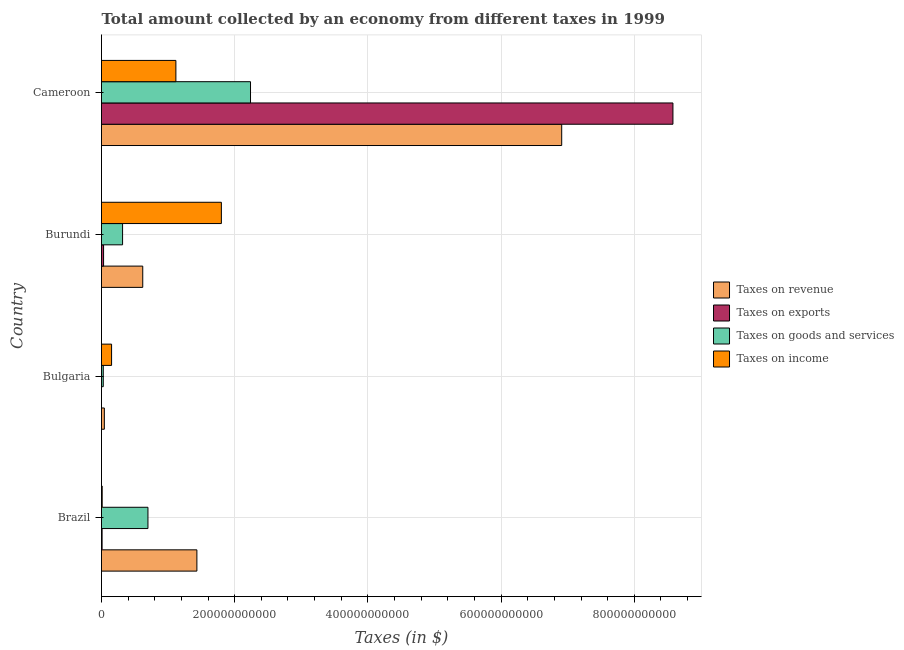How many different coloured bars are there?
Offer a very short reply. 4. How many groups of bars are there?
Provide a short and direct response. 4. Are the number of bars per tick equal to the number of legend labels?
Provide a short and direct response. No. Are the number of bars on each tick of the Y-axis equal?
Ensure brevity in your answer.  No. What is the label of the 2nd group of bars from the top?
Provide a short and direct response. Burundi. What is the amount collected as tax on income in Burundi?
Offer a terse response. 1.80e+11. Across all countries, what is the maximum amount collected as tax on exports?
Provide a succinct answer. 8.58e+11. Across all countries, what is the minimum amount collected as tax on revenue?
Provide a succinct answer. 4.26e+09. In which country was the amount collected as tax on goods maximum?
Offer a very short reply. Cameroon. What is the total amount collected as tax on goods in the graph?
Your response must be concise. 3.28e+11. What is the difference between the amount collected as tax on revenue in Brazil and that in Bulgaria?
Your answer should be very brief. 1.39e+11. What is the difference between the amount collected as tax on exports in Burundi and the amount collected as tax on revenue in Bulgaria?
Your answer should be very brief. -1.14e+09. What is the average amount collected as tax on income per country?
Give a very brief answer. 7.70e+1. What is the difference between the amount collected as tax on revenue and amount collected as tax on goods in Bulgaria?
Your answer should be very brief. 1.63e+09. What is the ratio of the amount collected as tax on income in Burundi to that in Cameroon?
Make the answer very short. 1.61. Is the amount collected as tax on income in Bulgaria less than that in Burundi?
Give a very brief answer. Yes. What is the difference between the highest and the second highest amount collected as tax on revenue?
Give a very brief answer. 5.48e+11. What is the difference between the highest and the lowest amount collected as tax on goods?
Offer a terse response. 2.21e+11. Is it the case that in every country, the sum of the amount collected as tax on revenue and amount collected as tax on income is greater than the sum of amount collected as tax on exports and amount collected as tax on goods?
Offer a terse response. No. Is it the case that in every country, the sum of the amount collected as tax on revenue and amount collected as tax on exports is greater than the amount collected as tax on goods?
Ensure brevity in your answer.  Yes. How many bars are there?
Provide a succinct answer. 15. What is the difference between two consecutive major ticks on the X-axis?
Provide a short and direct response. 2.00e+11. Are the values on the major ticks of X-axis written in scientific E-notation?
Offer a terse response. No. Does the graph contain any zero values?
Your response must be concise. Yes. Does the graph contain grids?
Provide a succinct answer. Yes. How are the legend labels stacked?
Your answer should be very brief. Vertical. What is the title of the graph?
Your response must be concise. Total amount collected by an economy from different taxes in 1999. What is the label or title of the X-axis?
Your response must be concise. Taxes (in $). What is the label or title of the Y-axis?
Ensure brevity in your answer.  Country. What is the Taxes (in $) in Taxes on revenue in Brazil?
Provide a succinct answer. 1.43e+11. What is the Taxes (in $) of Taxes on exports in Brazil?
Offer a terse response. 8.80e+08. What is the Taxes (in $) in Taxes on goods and services in Brazil?
Make the answer very short. 6.97e+1. What is the Taxes (in $) in Taxes on income in Brazil?
Make the answer very short. 1.03e+09. What is the Taxes (in $) in Taxes on revenue in Bulgaria?
Offer a very short reply. 4.26e+09. What is the Taxes (in $) in Taxes on goods and services in Bulgaria?
Your response must be concise. 2.63e+09. What is the Taxes (in $) of Taxes on income in Bulgaria?
Your response must be concise. 1.51e+1. What is the Taxes (in $) of Taxes on revenue in Burundi?
Offer a very short reply. 6.19e+1. What is the Taxes (in $) in Taxes on exports in Burundi?
Your response must be concise. 3.12e+09. What is the Taxes (in $) in Taxes on goods and services in Burundi?
Your answer should be compact. 3.16e+1. What is the Taxes (in $) of Taxes on income in Burundi?
Your answer should be very brief. 1.80e+11. What is the Taxes (in $) in Taxes on revenue in Cameroon?
Provide a short and direct response. 6.91e+11. What is the Taxes (in $) in Taxes on exports in Cameroon?
Offer a very short reply. 8.58e+11. What is the Taxes (in $) of Taxes on goods and services in Cameroon?
Keep it short and to the point. 2.24e+11. What is the Taxes (in $) in Taxes on income in Cameroon?
Your answer should be compact. 1.12e+11. Across all countries, what is the maximum Taxes (in $) of Taxes on revenue?
Give a very brief answer. 6.91e+11. Across all countries, what is the maximum Taxes (in $) of Taxes on exports?
Your answer should be very brief. 8.58e+11. Across all countries, what is the maximum Taxes (in $) in Taxes on goods and services?
Your response must be concise. 2.24e+11. Across all countries, what is the maximum Taxes (in $) in Taxes on income?
Provide a short and direct response. 1.80e+11. Across all countries, what is the minimum Taxes (in $) of Taxes on revenue?
Your response must be concise. 4.26e+09. Across all countries, what is the minimum Taxes (in $) in Taxes on goods and services?
Your response must be concise. 2.63e+09. Across all countries, what is the minimum Taxes (in $) in Taxes on income?
Your answer should be very brief. 1.03e+09. What is the total Taxes (in $) of Taxes on revenue in the graph?
Ensure brevity in your answer.  9.00e+11. What is the total Taxes (in $) of Taxes on exports in the graph?
Provide a succinct answer. 8.62e+11. What is the total Taxes (in $) in Taxes on goods and services in the graph?
Ensure brevity in your answer.  3.28e+11. What is the total Taxes (in $) in Taxes on income in the graph?
Provide a succinct answer. 3.08e+11. What is the difference between the Taxes (in $) of Taxes on revenue in Brazil and that in Bulgaria?
Provide a succinct answer. 1.39e+11. What is the difference between the Taxes (in $) of Taxes on goods and services in Brazil and that in Bulgaria?
Offer a very short reply. 6.71e+1. What is the difference between the Taxes (in $) in Taxes on income in Brazil and that in Bulgaria?
Your answer should be compact. -1.41e+1. What is the difference between the Taxes (in $) of Taxes on revenue in Brazil and that in Burundi?
Provide a short and direct response. 8.13e+1. What is the difference between the Taxes (in $) of Taxes on exports in Brazil and that in Burundi?
Give a very brief answer. -2.24e+09. What is the difference between the Taxes (in $) in Taxes on goods and services in Brazil and that in Burundi?
Offer a very short reply. 3.81e+1. What is the difference between the Taxes (in $) in Taxes on income in Brazil and that in Burundi?
Give a very brief answer. -1.79e+11. What is the difference between the Taxes (in $) in Taxes on revenue in Brazil and that in Cameroon?
Ensure brevity in your answer.  -5.48e+11. What is the difference between the Taxes (in $) of Taxes on exports in Brazil and that in Cameroon?
Give a very brief answer. -8.57e+11. What is the difference between the Taxes (in $) in Taxes on goods and services in Brazil and that in Cameroon?
Make the answer very short. -1.54e+11. What is the difference between the Taxes (in $) of Taxes on income in Brazil and that in Cameroon?
Provide a short and direct response. -1.11e+11. What is the difference between the Taxes (in $) in Taxes on revenue in Bulgaria and that in Burundi?
Your answer should be very brief. -5.77e+1. What is the difference between the Taxes (in $) of Taxes on goods and services in Bulgaria and that in Burundi?
Offer a terse response. -2.90e+1. What is the difference between the Taxes (in $) of Taxes on income in Bulgaria and that in Burundi?
Provide a short and direct response. -1.65e+11. What is the difference between the Taxes (in $) of Taxes on revenue in Bulgaria and that in Cameroon?
Offer a very short reply. -6.87e+11. What is the difference between the Taxes (in $) in Taxes on goods and services in Bulgaria and that in Cameroon?
Give a very brief answer. -2.21e+11. What is the difference between the Taxes (in $) of Taxes on income in Bulgaria and that in Cameroon?
Make the answer very short. -9.66e+1. What is the difference between the Taxes (in $) of Taxes on revenue in Burundi and that in Cameroon?
Offer a very short reply. -6.29e+11. What is the difference between the Taxes (in $) of Taxes on exports in Burundi and that in Cameroon?
Provide a succinct answer. -8.55e+11. What is the difference between the Taxes (in $) in Taxes on goods and services in Burundi and that in Cameroon?
Offer a very short reply. -1.92e+11. What is the difference between the Taxes (in $) in Taxes on income in Burundi and that in Cameroon?
Your response must be concise. 6.83e+1. What is the difference between the Taxes (in $) in Taxes on revenue in Brazil and the Taxes (in $) in Taxes on goods and services in Bulgaria?
Ensure brevity in your answer.  1.41e+11. What is the difference between the Taxes (in $) of Taxes on revenue in Brazil and the Taxes (in $) of Taxes on income in Bulgaria?
Your answer should be compact. 1.28e+11. What is the difference between the Taxes (in $) in Taxes on exports in Brazil and the Taxes (in $) in Taxes on goods and services in Bulgaria?
Ensure brevity in your answer.  -1.75e+09. What is the difference between the Taxes (in $) in Taxes on exports in Brazil and the Taxes (in $) in Taxes on income in Bulgaria?
Your response must be concise. -1.42e+1. What is the difference between the Taxes (in $) in Taxes on goods and services in Brazil and the Taxes (in $) in Taxes on income in Bulgaria?
Your answer should be compact. 5.46e+1. What is the difference between the Taxes (in $) of Taxes on revenue in Brazil and the Taxes (in $) of Taxes on exports in Burundi?
Give a very brief answer. 1.40e+11. What is the difference between the Taxes (in $) in Taxes on revenue in Brazil and the Taxes (in $) in Taxes on goods and services in Burundi?
Ensure brevity in your answer.  1.12e+11. What is the difference between the Taxes (in $) in Taxes on revenue in Brazil and the Taxes (in $) in Taxes on income in Burundi?
Keep it short and to the point. -3.68e+1. What is the difference between the Taxes (in $) in Taxes on exports in Brazil and the Taxes (in $) in Taxes on goods and services in Burundi?
Your answer should be very brief. -3.08e+1. What is the difference between the Taxes (in $) of Taxes on exports in Brazil and the Taxes (in $) of Taxes on income in Burundi?
Your response must be concise. -1.79e+11. What is the difference between the Taxes (in $) of Taxes on goods and services in Brazil and the Taxes (in $) of Taxes on income in Burundi?
Give a very brief answer. -1.10e+11. What is the difference between the Taxes (in $) of Taxes on revenue in Brazil and the Taxes (in $) of Taxes on exports in Cameroon?
Ensure brevity in your answer.  -7.15e+11. What is the difference between the Taxes (in $) of Taxes on revenue in Brazil and the Taxes (in $) of Taxes on goods and services in Cameroon?
Ensure brevity in your answer.  -8.05e+1. What is the difference between the Taxes (in $) in Taxes on revenue in Brazil and the Taxes (in $) in Taxes on income in Cameroon?
Provide a short and direct response. 3.15e+1. What is the difference between the Taxes (in $) in Taxes on exports in Brazil and the Taxes (in $) in Taxes on goods and services in Cameroon?
Provide a short and direct response. -2.23e+11. What is the difference between the Taxes (in $) of Taxes on exports in Brazil and the Taxes (in $) of Taxes on income in Cameroon?
Keep it short and to the point. -1.11e+11. What is the difference between the Taxes (in $) of Taxes on goods and services in Brazil and the Taxes (in $) of Taxes on income in Cameroon?
Make the answer very short. -4.20e+1. What is the difference between the Taxes (in $) in Taxes on revenue in Bulgaria and the Taxes (in $) in Taxes on exports in Burundi?
Keep it short and to the point. 1.14e+09. What is the difference between the Taxes (in $) in Taxes on revenue in Bulgaria and the Taxes (in $) in Taxes on goods and services in Burundi?
Ensure brevity in your answer.  -2.74e+1. What is the difference between the Taxes (in $) in Taxes on revenue in Bulgaria and the Taxes (in $) in Taxes on income in Burundi?
Your response must be concise. -1.76e+11. What is the difference between the Taxes (in $) in Taxes on goods and services in Bulgaria and the Taxes (in $) in Taxes on income in Burundi?
Offer a terse response. -1.77e+11. What is the difference between the Taxes (in $) in Taxes on revenue in Bulgaria and the Taxes (in $) in Taxes on exports in Cameroon?
Your response must be concise. -8.54e+11. What is the difference between the Taxes (in $) in Taxes on revenue in Bulgaria and the Taxes (in $) in Taxes on goods and services in Cameroon?
Keep it short and to the point. -2.19e+11. What is the difference between the Taxes (in $) in Taxes on revenue in Bulgaria and the Taxes (in $) in Taxes on income in Cameroon?
Give a very brief answer. -1.07e+11. What is the difference between the Taxes (in $) of Taxes on goods and services in Bulgaria and the Taxes (in $) of Taxes on income in Cameroon?
Your answer should be very brief. -1.09e+11. What is the difference between the Taxes (in $) of Taxes on revenue in Burundi and the Taxes (in $) of Taxes on exports in Cameroon?
Keep it short and to the point. -7.96e+11. What is the difference between the Taxes (in $) of Taxes on revenue in Burundi and the Taxes (in $) of Taxes on goods and services in Cameroon?
Make the answer very short. -1.62e+11. What is the difference between the Taxes (in $) of Taxes on revenue in Burundi and the Taxes (in $) of Taxes on income in Cameroon?
Keep it short and to the point. -4.98e+1. What is the difference between the Taxes (in $) of Taxes on exports in Burundi and the Taxes (in $) of Taxes on goods and services in Cameroon?
Provide a short and direct response. -2.21e+11. What is the difference between the Taxes (in $) in Taxes on exports in Burundi and the Taxes (in $) in Taxes on income in Cameroon?
Offer a very short reply. -1.09e+11. What is the difference between the Taxes (in $) in Taxes on goods and services in Burundi and the Taxes (in $) in Taxes on income in Cameroon?
Offer a terse response. -8.01e+1. What is the average Taxes (in $) of Taxes on revenue per country?
Give a very brief answer. 2.25e+11. What is the average Taxes (in $) of Taxes on exports per country?
Your response must be concise. 2.16e+11. What is the average Taxes (in $) of Taxes on goods and services per country?
Give a very brief answer. 8.19e+1. What is the average Taxes (in $) of Taxes on income per country?
Offer a terse response. 7.70e+1. What is the difference between the Taxes (in $) of Taxes on revenue and Taxes (in $) of Taxes on exports in Brazil?
Provide a succinct answer. 1.42e+11. What is the difference between the Taxes (in $) of Taxes on revenue and Taxes (in $) of Taxes on goods and services in Brazil?
Provide a short and direct response. 7.35e+1. What is the difference between the Taxes (in $) of Taxes on revenue and Taxes (in $) of Taxes on income in Brazil?
Give a very brief answer. 1.42e+11. What is the difference between the Taxes (in $) of Taxes on exports and Taxes (in $) of Taxes on goods and services in Brazil?
Make the answer very short. -6.89e+1. What is the difference between the Taxes (in $) in Taxes on exports and Taxes (in $) in Taxes on income in Brazil?
Your response must be concise. -1.49e+08. What is the difference between the Taxes (in $) in Taxes on goods and services and Taxes (in $) in Taxes on income in Brazil?
Your answer should be very brief. 6.87e+1. What is the difference between the Taxes (in $) of Taxes on revenue and Taxes (in $) of Taxes on goods and services in Bulgaria?
Ensure brevity in your answer.  1.63e+09. What is the difference between the Taxes (in $) in Taxes on revenue and Taxes (in $) in Taxes on income in Bulgaria?
Offer a terse response. -1.09e+1. What is the difference between the Taxes (in $) of Taxes on goods and services and Taxes (in $) of Taxes on income in Bulgaria?
Offer a terse response. -1.25e+1. What is the difference between the Taxes (in $) of Taxes on revenue and Taxes (in $) of Taxes on exports in Burundi?
Offer a terse response. 5.88e+1. What is the difference between the Taxes (in $) in Taxes on revenue and Taxes (in $) in Taxes on goods and services in Burundi?
Ensure brevity in your answer.  3.03e+1. What is the difference between the Taxes (in $) of Taxes on revenue and Taxes (in $) of Taxes on income in Burundi?
Provide a short and direct response. -1.18e+11. What is the difference between the Taxes (in $) of Taxes on exports and Taxes (in $) of Taxes on goods and services in Burundi?
Your response must be concise. -2.85e+1. What is the difference between the Taxes (in $) of Taxes on exports and Taxes (in $) of Taxes on income in Burundi?
Offer a very short reply. -1.77e+11. What is the difference between the Taxes (in $) of Taxes on goods and services and Taxes (in $) of Taxes on income in Burundi?
Offer a very short reply. -1.48e+11. What is the difference between the Taxes (in $) of Taxes on revenue and Taxes (in $) of Taxes on exports in Cameroon?
Provide a succinct answer. -1.67e+11. What is the difference between the Taxes (in $) of Taxes on revenue and Taxes (in $) of Taxes on goods and services in Cameroon?
Ensure brevity in your answer.  4.67e+11. What is the difference between the Taxes (in $) in Taxes on revenue and Taxes (in $) in Taxes on income in Cameroon?
Your response must be concise. 5.79e+11. What is the difference between the Taxes (in $) in Taxes on exports and Taxes (in $) in Taxes on goods and services in Cameroon?
Make the answer very short. 6.34e+11. What is the difference between the Taxes (in $) of Taxes on exports and Taxes (in $) of Taxes on income in Cameroon?
Offer a very short reply. 7.46e+11. What is the difference between the Taxes (in $) of Taxes on goods and services and Taxes (in $) of Taxes on income in Cameroon?
Your answer should be compact. 1.12e+11. What is the ratio of the Taxes (in $) in Taxes on revenue in Brazil to that in Bulgaria?
Provide a short and direct response. 33.62. What is the ratio of the Taxes (in $) of Taxes on goods and services in Brazil to that in Bulgaria?
Ensure brevity in your answer.  26.48. What is the ratio of the Taxes (in $) of Taxes on income in Brazil to that in Bulgaria?
Give a very brief answer. 0.07. What is the ratio of the Taxes (in $) of Taxes on revenue in Brazil to that in Burundi?
Keep it short and to the point. 2.31. What is the ratio of the Taxes (in $) in Taxes on exports in Brazil to that in Burundi?
Your answer should be compact. 0.28. What is the ratio of the Taxes (in $) of Taxes on goods and services in Brazil to that in Burundi?
Your answer should be very brief. 2.2. What is the ratio of the Taxes (in $) of Taxes on income in Brazil to that in Burundi?
Offer a very short reply. 0.01. What is the ratio of the Taxes (in $) in Taxes on revenue in Brazil to that in Cameroon?
Your answer should be compact. 0.21. What is the ratio of the Taxes (in $) of Taxes on goods and services in Brazil to that in Cameroon?
Ensure brevity in your answer.  0.31. What is the ratio of the Taxes (in $) in Taxes on income in Brazil to that in Cameroon?
Provide a succinct answer. 0.01. What is the ratio of the Taxes (in $) of Taxes on revenue in Bulgaria to that in Burundi?
Ensure brevity in your answer.  0.07. What is the ratio of the Taxes (in $) of Taxes on goods and services in Bulgaria to that in Burundi?
Ensure brevity in your answer.  0.08. What is the ratio of the Taxes (in $) of Taxes on income in Bulgaria to that in Burundi?
Ensure brevity in your answer.  0.08. What is the ratio of the Taxes (in $) of Taxes on revenue in Bulgaria to that in Cameroon?
Your response must be concise. 0.01. What is the ratio of the Taxes (in $) of Taxes on goods and services in Bulgaria to that in Cameroon?
Your response must be concise. 0.01. What is the ratio of the Taxes (in $) of Taxes on income in Bulgaria to that in Cameroon?
Offer a terse response. 0.14. What is the ratio of the Taxes (in $) of Taxes on revenue in Burundi to that in Cameroon?
Offer a terse response. 0.09. What is the ratio of the Taxes (in $) of Taxes on exports in Burundi to that in Cameroon?
Make the answer very short. 0. What is the ratio of the Taxes (in $) of Taxes on goods and services in Burundi to that in Cameroon?
Provide a succinct answer. 0.14. What is the ratio of the Taxes (in $) in Taxes on income in Burundi to that in Cameroon?
Your answer should be very brief. 1.61. What is the difference between the highest and the second highest Taxes (in $) of Taxes on revenue?
Offer a terse response. 5.48e+11. What is the difference between the highest and the second highest Taxes (in $) of Taxes on exports?
Your answer should be very brief. 8.55e+11. What is the difference between the highest and the second highest Taxes (in $) in Taxes on goods and services?
Your response must be concise. 1.54e+11. What is the difference between the highest and the second highest Taxes (in $) in Taxes on income?
Offer a very short reply. 6.83e+1. What is the difference between the highest and the lowest Taxes (in $) of Taxes on revenue?
Offer a very short reply. 6.87e+11. What is the difference between the highest and the lowest Taxes (in $) of Taxes on exports?
Your answer should be very brief. 8.58e+11. What is the difference between the highest and the lowest Taxes (in $) of Taxes on goods and services?
Give a very brief answer. 2.21e+11. What is the difference between the highest and the lowest Taxes (in $) of Taxes on income?
Your response must be concise. 1.79e+11. 